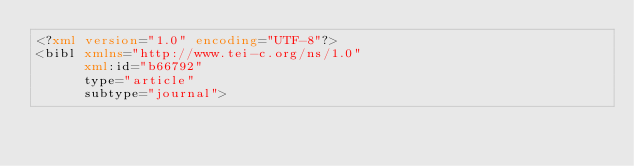<code> <loc_0><loc_0><loc_500><loc_500><_XML_><?xml version="1.0" encoding="UTF-8"?>
<bibl xmlns="http://www.tei-c.org/ns/1.0"
      xml:id="b66792"
      type="article"
      subtype="journal"></code> 